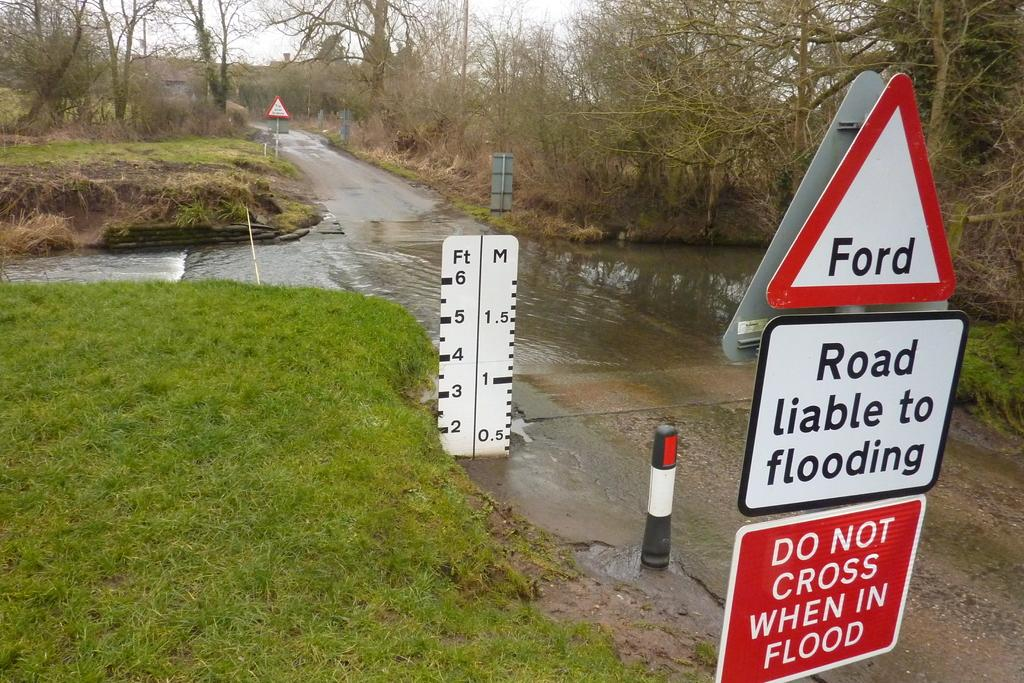<image>
Present a compact description of the photo's key features. A flooded road intersection with warning signs and flood stage indicator. 